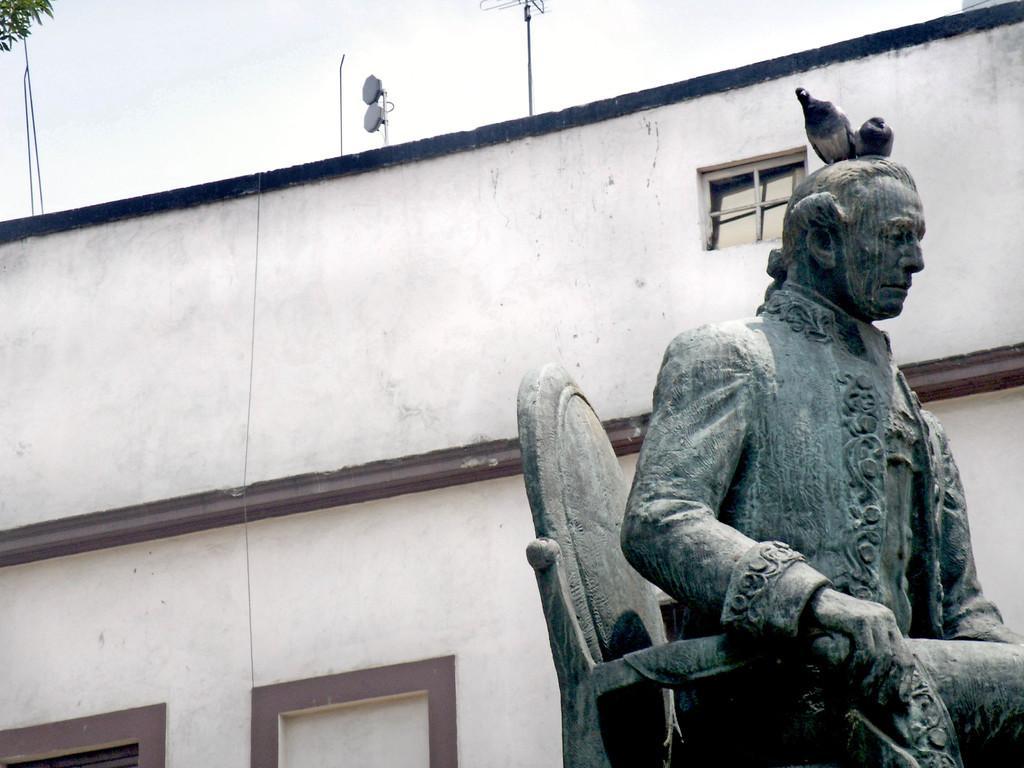In one or two sentences, can you explain what this image depicts? In this image, I can see two birds on the statue of a person. In the background, there is a building with the windows and the sky. At the top left corner of the image, there are leaves. 